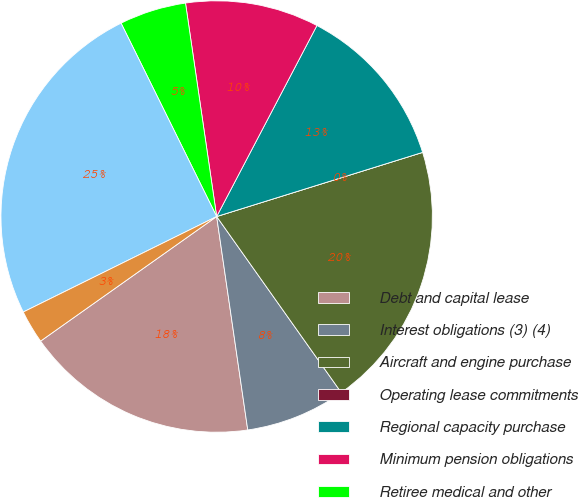Convert chart to OTSL. <chart><loc_0><loc_0><loc_500><loc_500><pie_chart><fcel>Debt and capital lease<fcel>Interest obligations (3) (4)<fcel>Aircraft and engine purchase<fcel>Operating lease commitments<fcel>Regional capacity purchase<fcel>Minimum pension obligations<fcel>Retiree medical and other<fcel>Total American Contractual<fcel>Interest obligations (3)<nl><fcel>17.5%<fcel>7.5%<fcel>20.0%<fcel>0.0%<fcel>12.5%<fcel>10.0%<fcel>5.0%<fcel>24.99%<fcel>2.5%<nl></chart> 